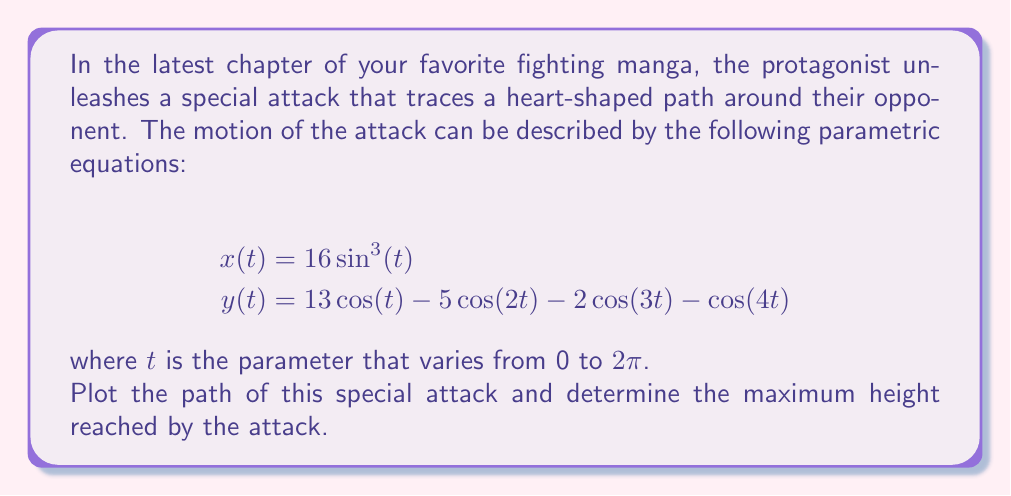Can you solve this math problem? To solve this problem, we'll follow these steps:

1) First, let's plot the parametric equations. We can use a graphing tool or software to do this, but here's a general idea of what the plot looks like:

[asy]
import graph;
size(200);
real x(real t) {return 16*sin(t)^3;}
real y(real t) {return 13*cos(t) - 5*cos(2t) - 2*cos(3t) - cos(4t);}
path g=graph(x,y,0,2pi,300);
draw(g,red);
xaxis("x");
yaxis("y");
[/asy]

This indeed traces out a heart-shaped path, as described in the question.

2) To find the maximum height, we need to find the maximum value of $y(t)$ over the interval $[0, 2\pi]$.

3) The $y$ coordinate is at its maximum when $\cos(t) = -1$ and $\cos(2t) = \cos(3t) = \cos(4t) = 1$. This occurs when $t = \pi$.

4) Let's calculate $y(\pi)$:

   $$\begin{align*}
   y(\pi) &= 13\cos(\pi) - 5\cos(2\pi) - 2\cos(3\pi) - \cos(4\pi) \\
   &= 13(-1) - 5(1) - 2(-1) - 1 \\
   &= -13 - 5 + 2 - 1 \\
   &= -17
   \end{align*}$$

5) Therefore, the maximum height reached by the attack is 17 units above the origin.
Answer: The maximum height reached by the special attack is 17 units. 